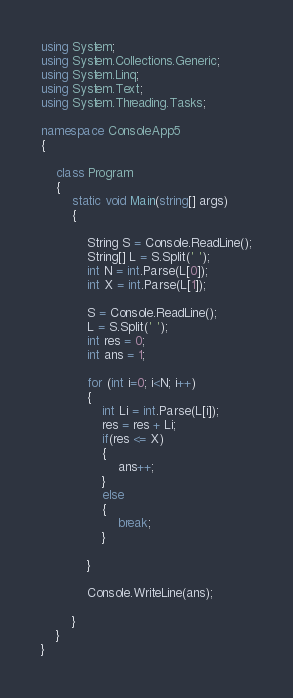Convert code to text. <code><loc_0><loc_0><loc_500><loc_500><_C#_>using System;
using System.Collections.Generic;
using System.Linq;
using System.Text;
using System.Threading.Tasks;

namespace ConsoleApp5
{

    class Program
    {
        static void Main(string[] args)
        {

            String S = Console.ReadLine();
            String[] L = S.Split(' ');
            int N = int.Parse(L[0]);
            int X = int.Parse(L[1]);

            S = Console.ReadLine();
            L = S.Split(' ');
            int res = 0;
            int ans = 1;

            for (int i=0; i<N; i++)
            {
                int Li = int.Parse(L[i]);
                res = res + Li;
                if(res <= X)
                {
                    ans++;
                }
                else
                {
                    break;
                }

            }

            Console.WriteLine(ans);

        }
    }
}</code> 